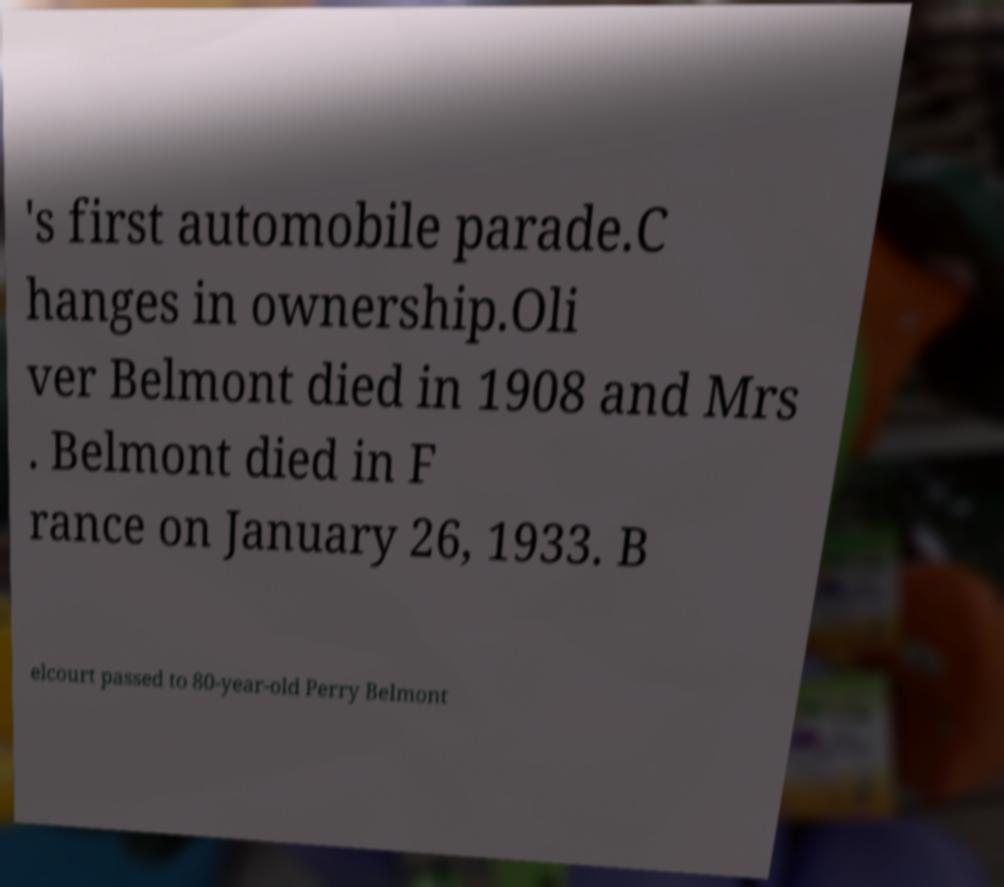Please identify and transcribe the text found in this image. 's first automobile parade.C hanges in ownership.Oli ver Belmont died in 1908 and Mrs . Belmont died in F rance on January 26, 1933. B elcourt passed to 80-year-old Perry Belmont 